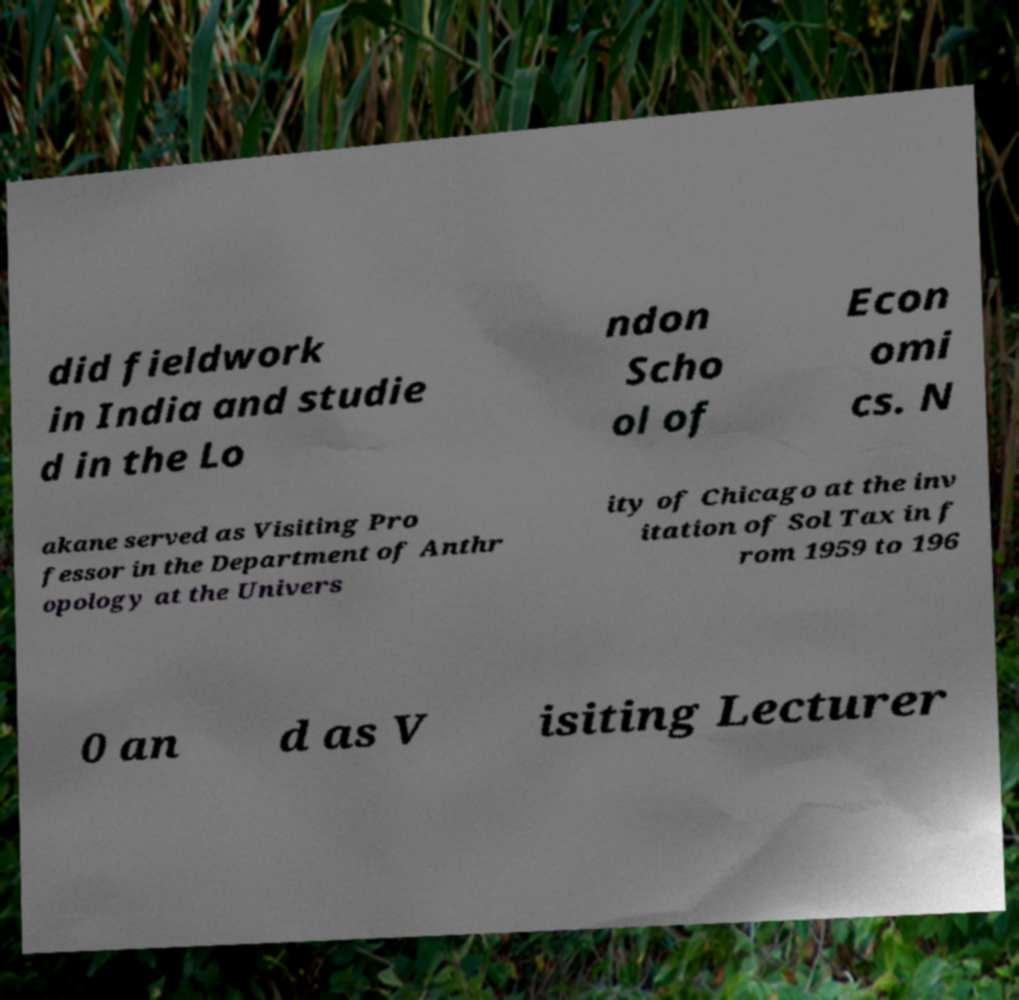Could you assist in decoding the text presented in this image and type it out clearly? did fieldwork in India and studie d in the Lo ndon Scho ol of Econ omi cs. N akane served as Visiting Pro fessor in the Department of Anthr opology at the Univers ity of Chicago at the inv itation of Sol Tax in f rom 1959 to 196 0 an d as V isiting Lecturer 